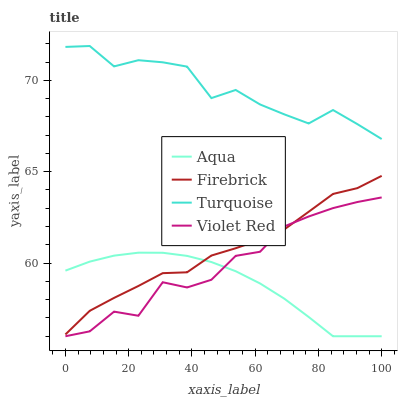Does Aqua have the minimum area under the curve?
Answer yes or no. Yes. Does Turquoise have the maximum area under the curve?
Answer yes or no. Yes. Does Firebrick have the minimum area under the curve?
Answer yes or no. No. Does Firebrick have the maximum area under the curve?
Answer yes or no. No. Is Aqua the smoothest?
Answer yes or no. Yes. Is Violet Red the roughest?
Answer yes or no. Yes. Is Firebrick the smoothest?
Answer yes or no. No. Is Firebrick the roughest?
Answer yes or no. No. Does Violet Red have the lowest value?
Answer yes or no. Yes. Does Firebrick have the lowest value?
Answer yes or no. No. Does Turquoise have the highest value?
Answer yes or no. Yes. Does Firebrick have the highest value?
Answer yes or no. No. Is Aqua less than Turquoise?
Answer yes or no. Yes. Is Turquoise greater than Aqua?
Answer yes or no. Yes. Does Firebrick intersect Violet Red?
Answer yes or no. Yes. Is Firebrick less than Violet Red?
Answer yes or no. No. Is Firebrick greater than Violet Red?
Answer yes or no. No. Does Aqua intersect Turquoise?
Answer yes or no. No. 